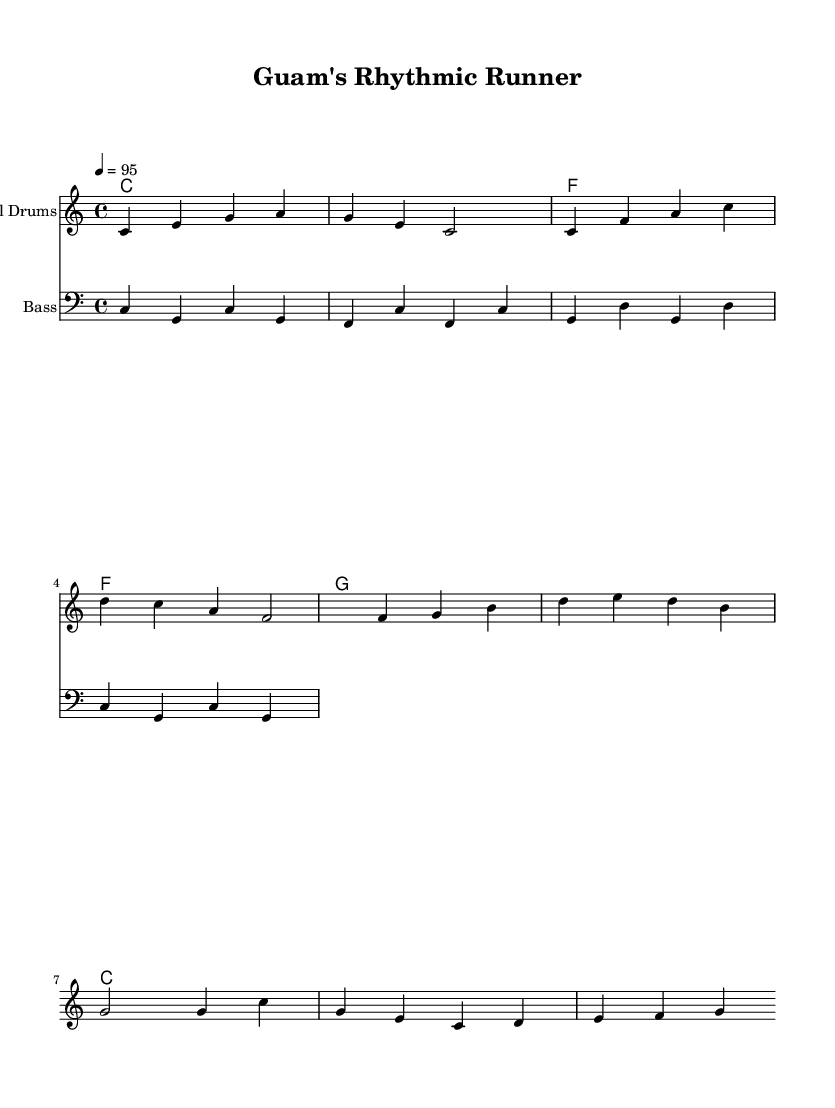What is the key signature of this music? The key signature is C major, which is indicated by the absence of sharps or flats in the score.
Answer: C major What is the time signature of this music? The time signature is indicated at the beginning of the score as 4/4, meaning there are four beats in each measure and the quarter note gets one beat.
Answer: 4/4 What is the tempo marking indicated in the music? The tempo marking shows that the piece is set to 95 beats per minute, which is indicated by "4 = 95" at the start of the score.
Answer: 95 How many measures are present in the melody section? Counting the measures in the melody section, there are a total of eight measures present in the staff.
Answer: 8 What type of instruments are featured in this score? The score includes a staff labeled "Steel Drums" and another staff labeled "Bass," indicating that these two instruments are featured.
Answer: Steel Drums, Bass Which chord is played in the first measure? The first measure shows a C chord written as "c1," signifying that the chord played is C major.
Answer: C major What rhythmic feel is emphasized in the melody? The melody uses a syncopated feel common in reggae music, utilizing off-beat rhythms to create a laid-back groove.
Answer: Syncopated 